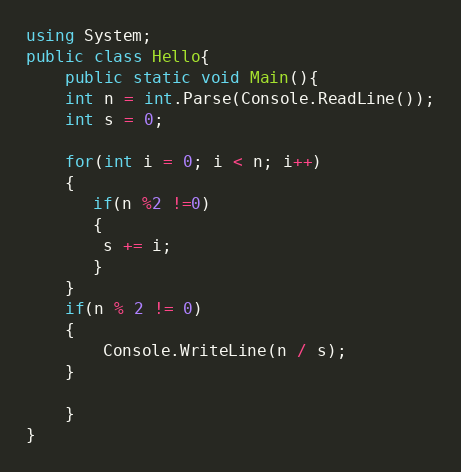Convert code to text. <code><loc_0><loc_0><loc_500><loc_500><_C#_>using System;
public class Hello{
    public static void Main(){
    int n = int.Parse(Console.ReadLine());
    int s = 0;

    for(int i = 0; i < n; i++)
    {
       if(n %2 !=0)
       {
        s += i;
       }
    }
    if(n % 2 != 0)
    {
        Console.WriteLine(n / s);
    }
 
    }
}
</code> 